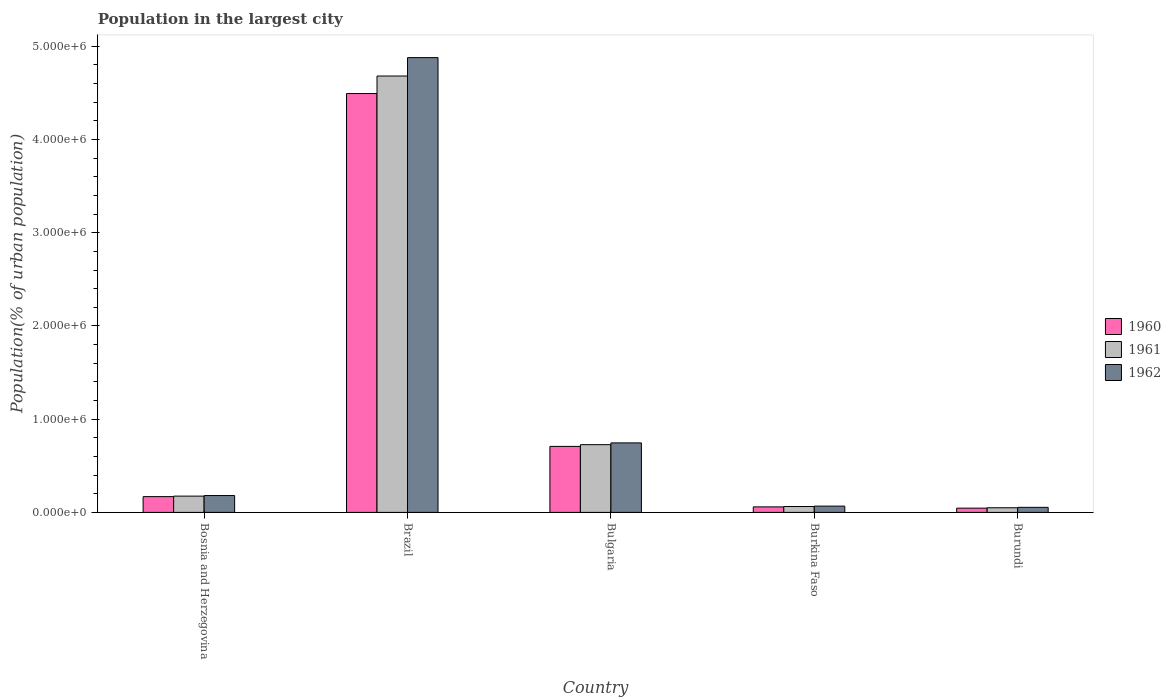How many different coloured bars are there?
Give a very brief answer. 3. Are the number of bars per tick equal to the number of legend labels?
Make the answer very short. Yes. Are the number of bars on each tick of the X-axis equal?
Keep it short and to the point. Yes. How many bars are there on the 4th tick from the left?
Your answer should be compact. 3. What is the label of the 4th group of bars from the left?
Ensure brevity in your answer.  Burkina Faso. What is the population in the largest city in 1960 in Bulgaria?
Offer a terse response. 7.08e+05. Across all countries, what is the maximum population in the largest city in 1961?
Offer a terse response. 4.68e+06. Across all countries, what is the minimum population in the largest city in 1960?
Keep it short and to the point. 4.56e+04. In which country was the population in the largest city in 1961 maximum?
Your answer should be very brief. Brazil. In which country was the population in the largest city in 1962 minimum?
Offer a terse response. Burundi. What is the total population in the largest city in 1961 in the graph?
Ensure brevity in your answer.  5.70e+06. What is the difference between the population in the largest city in 1962 in Burkina Faso and that in Burundi?
Your response must be concise. 1.30e+04. What is the difference between the population in the largest city in 1961 in Bosnia and Herzegovina and the population in the largest city in 1960 in Bulgaria?
Offer a very short reply. -5.33e+05. What is the average population in the largest city in 1961 per country?
Ensure brevity in your answer.  1.14e+06. What is the difference between the population in the largest city of/in 1962 and population in the largest city of/in 1960 in Bosnia and Herzegovina?
Offer a terse response. 1.14e+04. What is the ratio of the population in the largest city in 1960 in Brazil to that in Burkina Faso?
Your answer should be compact. 75.99. What is the difference between the highest and the second highest population in the largest city in 1961?
Offer a terse response. -3.95e+06. What is the difference between the highest and the lowest population in the largest city in 1960?
Offer a terse response. 4.45e+06. In how many countries, is the population in the largest city in 1961 greater than the average population in the largest city in 1961 taken over all countries?
Give a very brief answer. 1. What does the 2nd bar from the left in Bulgaria represents?
Keep it short and to the point. 1961. How many countries are there in the graph?
Ensure brevity in your answer.  5. Are the values on the major ticks of Y-axis written in scientific E-notation?
Your answer should be compact. Yes. Does the graph contain grids?
Your response must be concise. No. How are the legend labels stacked?
Give a very brief answer. Vertical. What is the title of the graph?
Keep it short and to the point. Population in the largest city. What is the label or title of the X-axis?
Offer a terse response. Country. What is the label or title of the Y-axis?
Offer a very short reply. Population(% of urban population). What is the Population(% of urban population) of 1960 in Bosnia and Herzegovina?
Provide a succinct answer. 1.69e+05. What is the Population(% of urban population) in 1961 in Bosnia and Herzegovina?
Make the answer very short. 1.75e+05. What is the Population(% of urban population) in 1962 in Bosnia and Herzegovina?
Offer a terse response. 1.81e+05. What is the Population(% of urban population) of 1960 in Brazil?
Your answer should be compact. 4.49e+06. What is the Population(% of urban population) of 1961 in Brazil?
Your response must be concise. 4.68e+06. What is the Population(% of urban population) in 1962 in Brazil?
Your response must be concise. 4.88e+06. What is the Population(% of urban population) of 1960 in Bulgaria?
Ensure brevity in your answer.  7.08e+05. What is the Population(% of urban population) of 1961 in Bulgaria?
Offer a very short reply. 7.27e+05. What is the Population(% of urban population) of 1962 in Bulgaria?
Give a very brief answer. 7.46e+05. What is the Population(% of urban population) in 1960 in Burkina Faso?
Keep it short and to the point. 5.91e+04. What is the Population(% of urban population) of 1961 in Burkina Faso?
Provide a short and direct response. 6.31e+04. What is the Population(% of urban population) in 1962 in Burkina Faso?
Provide a short and direct response. 6.73e+04. What is the Population(% of urban population) of 1960 in Burundi?
Your answer should be compact. 4.56e+04. What is the Population(% of urban population) in 1961 in Burundi?
Make the answer very short. 4.98e+04. What is the Population(% of urban population) of 1962 in Burundi?
Your answer should be very brief. 5.44e+04. Across all countries, what is the maximum Population(% of urban population) of 1960?
Offer a terse response. 4.49e+06. Across all countries, what is the maximum Population(% of urban population) in 1961?
Ensure brevity in your answer.  4.68e+06. Across all countries, what is the maximum Population(% of urban population) in 1962?
Give a very brief answer. 4.88e+06. Across all countries, what is the minimum Population(% of urban population) in 1960?
Make the answer very short. 4.56e+04. Across all countries, what is the minimum Population(% of urban population) of 1961?
Offer a very short reply. 4.98e+04. Across all countries, what is the minimum Population(% of urban population) in 1962?
Offer a terse response. 5.44e+04. What is the total Population(% of urban population) of 1960 in the graph?
Provide a succinct answer. 5.48e+06. What is the total Population(% of urban population) in 1961 in the graph?
Your answer should be very brief. 5.70e+06. What is the total Population(% of urban population) of 1962 in the graph?
Make the answer very short. 5.93e+06. What is the difference between the Population(% of urban population) in 1960 in Bosnia and Herzegovina and that in Brazil?
Offer a very short reply. -4.32e+06. What is the difference between the Population(% of urban population) of 1961 in Bosnia and Herzegovina and that in Brazil?
Your answer should be very brief. -4.51e+06. What is the difference between the Population(% of urban population) in 1962 in Bosnia and Herzegovina and that in Brazil?
Give a very brief answer. -4.70e+06. What is the difference between the Population(% of urban population) in 1960 in Bosnia and Herzegovina and that in Bulgaria?
Your answer should be compact. -5.39e+05. What is the difference between the Population(% of urban population) of 1961 in Bosnia and Herzegovina and that in Bulgaria?
Your answer should be compact. -5.52e+05. What is the difference between the Population(% of urban population) of 1962 in Bosnia and Herzegovina and that in Bulgaria?
Give a very brief answer. -5.65e+05. What is the difference between the Population(% of urban population) of 1960 in Bosnia and Herzegovina and that in Burkina Faso?
Your answer should be compact. 1.10e+05. What is the difference between the Population(% of urban population) in 1961 in Bosnia and Herzegovina and that in Burkina Faso?
Your answer should be very brief. 1.12e+05. What is the difference between the Population(% of urban population) in 1962 in Bosnia and Herzegovina and that in Burkina Faso?
Offer a very short reply. 1.13e+05. What is the difference between the Population(% of urban population) of 1960 in Bosnia and Herzegovina and that in Burundi?
Give a very brief answer. 1.24e+05. What is the difference between the Population(% of urban population) of 1961 in Bosnia and Herzegovina and that in Burundi?
Your answer should be very brief. 1.25e+05. What is the difference between the Population(% of urban population) in 1962 in Bosnia and Herzegovina and that in Burundi?
Offer a terse response. 1.26e+05. What is the difference between the Population(% of urban population) of 1960 in Brazil and that in Bulgaria?
Your answer should be compact. 3.79e+06. What is the difference between the Population(% of urban population) of 1961 in Brazil and that in Bulgaria?
Offer a very short reply. 3.95e+06. What is the difference between the Population(% of urban population) in 1962 in Brazil and that in Bulgaria?
Offer a terse response. 4.13e+06. What is the difference between the Population(% of urban population) in 1960 in Brazil and that in Burkina Faso?
Offer a terse response. 4.43e+06. What is the difference between the Population(% of urban population) in 1961 in Brazil and that in Burkina Faso?
Offer a very short reply. 4.62e+06. What is the difference between the Population(% of urban population) in 1962 in Brazil and that in Burkina Faso?
Offer a terse response. 4.81e+06. What is the difference between the Population(% of urban population) of 1960 in Brazil and that in Burundi?
Keep it short and to the point. 4.45e+06. What is the difference between the Population(% of urban population) in 1961 in Brazil and that in Burundi?
Give a very brief answer. 4.63e+06. What is the difference between the Population(% of urban population) in 1962 in Brazil and that in Burundi?
Your response must be concise. 4.82e+06. What is the difference between the Population(% of urban population) of 1960 in Bulgaria and that in Burkina Faso?
Make the answer very short. 6.49e+05. What is the difference between the Population(% of urban population) of 1961 in Bulgaria and that in Burkina Faso?
Offer a very short reply. 6.63e+05. What is the difference between the Population(% of urban population) of 1962 in Bulgaria and that in Burkina Faso?
Make the answer very short. 6.78e+05. What is the difference between the Population(% of urban population) in 1960 in Bulgaria and that in Burundi?
Your answer should be very brief. 6.62e+05. What is the difference between the Population(% of urban population) of 1961 in Bulgaria and that in Burundi?
Offer a terse response. 6.77e+05. What is the difference between the Population(% of urban population) of 1962 in Bulgaria and that in Burundi?
Provide a short and direct response. 6.91e+05. What is the difference between the Population(% of urban population) of 1960 in Burkina Faso and that in Burundi?
Your response must be concise. 1.36e+04. What is the difference between the Population(% of urban population) in 1961 in Burkina Faso and that in Burundi?
Your answer should be very brief. 1.33e+04. What is the difference between the Population(% of urban population) in 1962 in Burkina Faso and that in Burundi?
Your response must be concise. 1.30e+04. What is the difference between the Population(% of urban population) in 1960 in Bosnia and Herzegovina and the Population(% of urban population) in 1961 in Brazil?
Provide a succinct answer. -4.51e+06. What is the difference between the Population(% of urban population) of 1960 in Bosnia and Herzegovina and the Population(% of urban population) of 1962 in Brazil?
Your answer should be very brief. -4.71e+06. What is the difference between the Population(% of urban population) in 1961 in Bosnia and Herzegovina and the Population(% of urban population) in 1962 in Brazil?
Provide a succinct answer. -4.70e+06. What is the difference between the Population(% of urban population) in 1960 in Bosnia and Herzegovina and the Population(% of urban population) in 1961 in Bulgaria?
Offer a very short reply. -5.57e+05. What is the difference between the Population(% of urban population) of 1960 in Bosnia and Herzegovina and the Population(% of urban population) of 1962 in Bulgaria?
Make the answer very short. -5.76e+05. What is the difference between the Population(% of urban population) of 1961 in Bosnia and Herzegovina and the Population(% of urban population) of 1962 in Bulgaria?
Ensure brevity in your answer.  -5.71e+05. What is the difference between the Population(% of urban population) of 1960 in Bosnia and Herzegovina and the Population(% of urban population) of 1961 in Burkina Faso?
Offer a very short reply. 1.06e+05. What is the difference between the Population(% of urban population) in 1960 in Bosnia and Herzegovina and the Population(% of urban population) in 1962 in Burkina Faso?
Your answer should be very brief. 1.02e+05. What is the difference between the Population(% of urban population) of 1961 in Bosnia and Herzegovina and the Population(% of urban population) of 1962 in Burkina Faso?
Your answer should be very brief. 1.07e+05. What is the difference between the Population(% of urban population) in 1960 in Bosnia and Herzegovina and the Population(% of urban population) in 1961 in Burundi?
Keep it short and to the point. 1.20e+05. What is the difference between the Population(% of urban population) in 1960 in Bosnia and Herzegovina and the Population(% of urban population) in 1962 in Burundi?
Keep it short and to the point. 1.15e+05. What is the difference between the Population(% of urban population) in 1961 in Bosnia and Herzegovina and the Population(% of urban population) in 1962 in Burundi?
Make the answer very short. 1.20e+05. What is the difference between the Population(% of urban population) of 1960 in Brazil and the Population(% of urban population) of 1961 in Bulgaria?
Your answer should be compact. 3.77e+06. What is the difference between the Population(% of urban population) of 1960 in Brazil and the Population(% of urban population) of 1962 in Bulgaria?
Give a very brief answer. 3.75e+06. What is the difference between the Population(% of urban population) in 1961 in Brazil and the Population(% of urban population) in 1962 in Bulgaria?
Ensure brevity in your answer.  3.94e+06. What is the difference between the Population(% of urban population) of 1960 in Brazil and the Population(% of urban population) of 1961 in Burkina Faso?
Make the answer very short. 4.43e+06. What is the difference between the Population(% of urban population) of 1960 in Brazil and the Population(% of urban population) of 1962 in Burkina Faso?
Ensure brevity in your answer.  4.43e+06. What is the difference between the Population(% of urban population) of 1961 in Brazil and the Population(% of urban population) of 1962 in Burkina Faso?
Keep it short and to the point. 4.61e+06. What is the difference between the Population(% of urban population) of 1960 in Brazil and the Population(% of urban population) of 1961 in Burundi?
Your answer should be very brief. 4.44e+06. What is the difference between the Population(% of urban population) of 1960 in Brazil and the Population(% of urban population) of 1962 in Burundi?
Offer a terse response. 4.44e+06. What is the difference between the Population(% of urban population) of 1961 in Brazil and the Population(% of urban population) of 1962 in Burundi?
Your answer should be compact. 4.63e+06. What is the difference between the Population(% of urban population) in 1960 in Bulgaria and the Population(% of urban population) in 1961 in Burkina Faso?
Make the answer very short. 6.45e+05. What is the difference between the Population(% of urban population) of 1960 in Bulgaria and the Population(% of urban population) of 1962 in Burkina Faso?
Your answer should be very brief. 6.41e+05. What is the difference between the Population(% of urban population) of 1961 in Bulgaria and the Population(% of urban population) of 1962 in Burkina Faso?
Give a very brief answer. 6.59e+05. What is the difference between the Population(% of urban population) of 1960 in Bulgaria and the Population(% of urban population) of 1961 in Burundi?
Ensure brevity in your answer.  6.58e+05. What is the difference between the Population(% of urban population) in 1960 in Bulgaria and the Population(% of urban population) in 1962 in Burundi?
Ensure brevity in your answer.  6.54e+05. What is the difference between the Population(% of urban population) of 1961 in Bulgaria and the Population(% of urban population) of 1962 in Burundi?
Make the answer very short. 6.72e+05. What is the difference between the Population(% of urban population) of 1960 in Burkina Faso and the Population(% of urban population) of 1961 in Burundi?
Provide a short and direct response. 9358. What is the difference between the Population(% of urban population) of 1960 in Burkina Faso and the Population(% of urban population) of 1962 in Burundi?
Provide a short and direct response. 4759. What is the difference between the Population(% of urban population) of 1961 in Burkina Faso and the Population(% of urban population) of 1962 in Burundi?
Your response must be concise. 8723. What is the average Population(% of urban population) in 1960 per country?
Make the answer very short. 1.10e+06. What is the average Population(% of urban population) of 1961 per country?
Offer a very short reply. 1.14e+06. What is the average Population(% of urban population) in 1962 per country?
Offer a very short reply. 1.19e+06. What is the difference between the Population(% of urban population) of 1960 and Population(% of urban population) of 1961 in Bosnia and Herzegovina?
Make the answer very short. -5328. What is the difference between the Population(% of urban population) of 1960 and Population(% of urban population) of 1962 in Bosnia and Herzegovina?
Keep it short and to the point. -1.14e+04. What is the difference between the Population(% of urban population) in 1961 and Population(% of urban population) in 1962 in Bosnia and Herzegovina?
Offer a very short reply. -6094. What is the difference between the Population(% of urban population) of 1960 and Population(% of urban population) of 1961 in Brazil?
Provide a short and direct response. -1.88e+05. What is the difference between the Population(% of urban population) in 1960 and Population(% of urban population) in 1962 in Brazil?
Provide a short and direct response. -3.85e+05. What is the difference between the Population(% of urban population) of 1961 and Population(% of urban population) of 1962 in Brazil?
Give a very brief answer. -1.98e+05. What is the difference between the Population(% of urban population) in 1960 and Population(% of urban population) in 1961 in Bulgaria?
Give a very brief answer. -1.85e+04. What is the difference between the Population(% of urban population) in 1960 and Population(% of urban population) in 1962 in Bulgaria?
Provide a short and direct response. -3.75e+04. What is the difference between the Population(% of urban population) in 1961 and Population(% of urban population) in 1962 in Bulgaria?
Offer a terse response. -1.90e+04. What is the difference between the Population(% of urban population) of 1960 and Population(% of urban population) of 1961 in Burkina Faso?
Your answer should be compact. -3964. What is the difference between the Population(% of urban population) in 1960 and Population(% of urban population) in 1962 in Burkina Faso?
Your answer should be compact. -8199. What is the difference between the Population(% of urban population) in 1961 and Population(% of urban population) in 1962 in Burkina Faso?
Make the answer very short. -4235. What is the difference between the Population(% of urban population) in 1960 and Population(% of urban population) in 1961 in Burundi?
Provide a succinct answer. -4204. What is the difference between the Population(% of urban population) of 1960 and Population(% of urban population) of 1962 in Burundi?
Give a very brief answer. -8803. What is the difference between the Population(% of urban population) of 1961 and Population(% of urban population) of 1962 in Burundi?
Offer a very short reply. -4599. What is the ratio of the Population(% of urban population) in 1960 in Bosnia and Herzegovina to that in Brazil?
Your answer should be very brief. 0.04. What is the ratio of the Population(% of urban population) of 1961 in Bosnia and Herzegovina to that in Brazil?
Make the answer very short. 0.04. What is the ratio of the Population(% of urban population) of 1962 in Bosnia and Herzegovina to that in Brazil?
Offer a terse response. 0.04. What is the ratio of the Population(% of urban population) in 1960 in Bosnia and Herzegovina to that in Bulgaria?
Your answer should be compact. 0.24. What is the ratio of the Population(% of urban population) in 1961 in Bosnia and Herzegovina to that in Bulgaria?
Your answer should be compact. 0.24. What is the ratio of the Population(% of urban population) in 1962 in Bosnia and Herzegovina to that in Bulgaria?
Ensure brevity in your answer.  0.24. What is the ratio of the Population(% of urban population) in 1960 in Bosnia and Herzegovina to that in Burkina Faso?
Your answer should be compact. 2.86. What is the ratio of the Population(% of urban population) of 1961 in Bosnia and Herzegovina to that in Burkina Faso?
Provide a succinct answer. 2.77. What is the ratio of the Population(% of urban population) of 1962 in Bosnia and Herzegovina to that in Burkina Faso?
Your answer should be compact. 2.68. What is the ratio of the Population(% of urban population) of 1960 in Bosnia and Herzegovina to that in Burundi?
Offer a very short reply. 3.72. What is the ratio of the Population(% of urban population) in 1961 in Bosnia and Herzegovina to that in Burundi?
Offer a terse response. 3.51. What is the ratio of the Population(% of urban population) of 1962 in Bosnia and Herzegovina to that in Burundi?
Make the answer very short. 3.32. What is the ratio of the Population(% of urban population) in 1960 in Brazil to that in Bulgaria?
Ensure brevity in your answer.  6.35. What is the ratio of the Population(% of urban population) of 1961 in Brazil to that in Bulgaria?
Offer a very short reply. 6.44. What is the ratio of the Population(% of urban population) in 1962 in Brazil to that in Bulgaria?
Ensure brevity in your answer.  6.54. What is the ratio of the Population(% of urban population) of 1960 in Brazil to that in Burkina Faso?
Keep it short and to the point. 75.99. What is the ratio of the Population(% of urban population) in 1961 in Brazil to that in Burkina Faso?
Keep it short and to the point. 74.2. What is the ratio of the Population(% of urban population) in 1962 in Brazil to that in Burkina Faso?
Give a very brief answer. 72.46. What is the ratio of the Population(% of urban population) in 1960 in Brazil to that in Burundi?
Provide a short and direct response. 98.61. What is the ratio of the Population(% of urban population) in 1961 in Brazil to that in Burundi?
Provide a succinct answer. 94.06. What is the ratio of the Population(% of urban population) in 1962 in Brazil to that in Burundi?
Keep it short and to the point. 89.73. What is the ratio of the Population(% of urban population) in 1960 in Bulgaria to that in Burkina Faso?
Provide a short and direct response. 11.98. What is the ratio of the Population(% of urban population) in 1961 in Bulgaria to that in Burkina Faso?
Provide a succinct answer. 11.52. What is the ratio of the Population(% of urban population) in 1962 in Bulgaria to that in Burkina Faso?
Ensure brevity in your answer.  11.07. What is the ratio of the Population(% of urban population) in 1960 in Bulgaria to that in Burundi?
Make the answer very short. 15.54. What is the ratio of the Population(% of urban population) in 1961 in Bulgaria to that in Burundi?
Provide a succinct answer. 14.6. What is the ratio of the Population(% of urban population) of 1962 in Bulgaria to that in Burundi?
Offer a very short reply. 13.71. What is the ratio of the Population(% of urban population) of 1960 in Burkina Faso to that in Burundi?
Keep it short and to the point. 1.3. What is the ratio of the Population(% of urban population) in 1961 in Burkina Faso to that in Burundi?
Your answer should be compact. 1.27. What is the ratio of the Population(% of urban population) of 1962 in Burkina Faso to that in Burundi?
Make the answer very short. 1.24. What is the difference between the highest and the second highest Population(% of urban population) of 1960?
Keep it short and to the point. 3.79e+06. What is the difference between the highest and the second highest Population(% of urban population) in 1961?
Offer a terse response. 3.95e+06. What is the difference between the highest and the second highest Population(% of urban population) in 1962?
Offer a terse response. 4.13e+06. What is the difference between the highest and the lowest Population(% of urban population) of 1960?
Offer a very short reply. 4.45e+06. What is the difference between the highest and the lowest Population(% of urban population) of 1961?
Give a very brief answer. 4.63e+06. What is the difference between the highest and the lowest Population(% of urban population) in 1962?
Keep it short and to the point. 4.82e+06. 